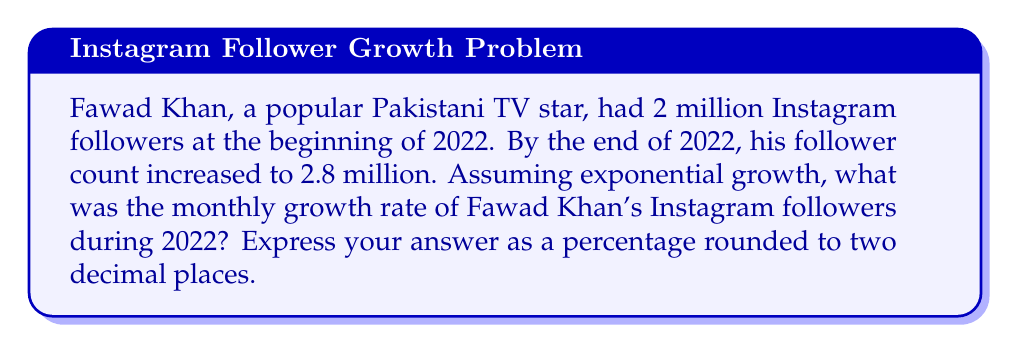Could you help me with this problem? To solve this problem, we'll use the exponential growth formula:

$$A = P(1 + r)^t$$

Where:
$A$ = Final amount (2.8 million followers)
$P$ = Initial amount (2 million followers)
$r$ = Monthly growth rate (what we're solving for)
$t$ = Number of months (12, as we're calculating for the entire year)

1. Substitute the known values into the formula:
   $$2.8 = 2(1 + r)^{12}$$

2. Divide both sides by 2:
   $$1.4 = (1 + r)^{12}$$

3. Take the 12th root of both sides:
   $$\sqrt[12]{1.4} = 1 + r$$

4. Subtract 1 from both sides:
   $$\sqrt[12]{1.4} - 1 = r$$

5. Calculate the value:
   $$r \approx 0.0283$$

6. Convert to a percentage by multiplying by 100:
   $$r \approx 2.83\%$$

7. Round to two decimal places:
   $$r \approx 2.83\%$$
Answer: 2.83% 